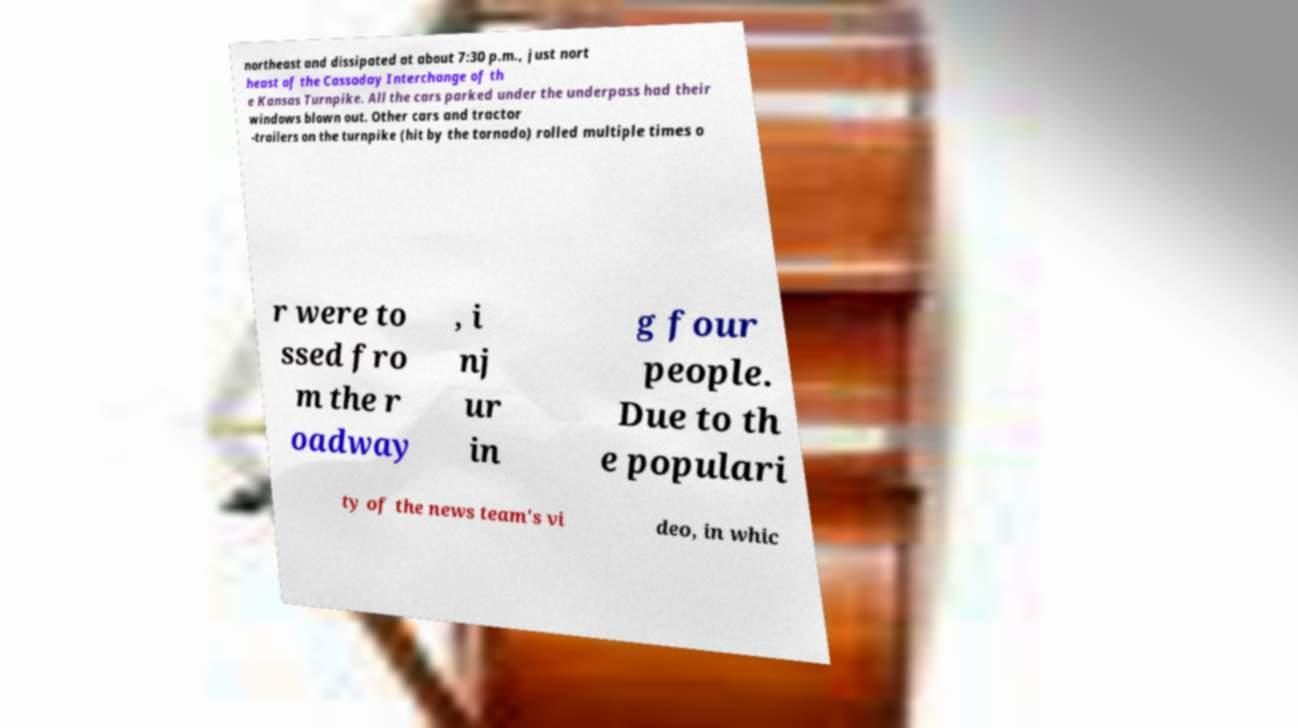I need the written content from this picture converted into text. Can you do that? northeast and dissipated at about 7:30 p.m., just nort heast of the Cassoday Interchange of th e Kansas Turnpike. All the cars parked under the underpass had their windows blown out. Other cars and tractor -trailers on the turnpike (hit by the tornado) rolled multiple times o r were to ssed fro m the r oadway , i nj ur in g four people. Due to th e populari ty of the news team's vi deo, in whic 